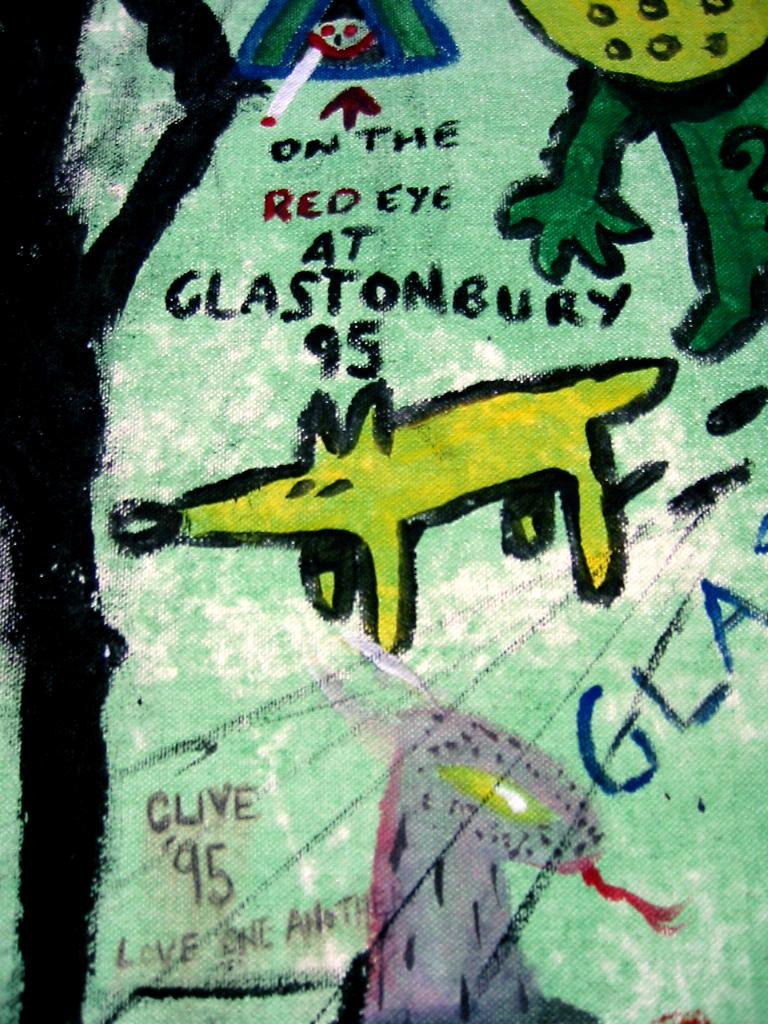<image>
Relay a brief, clear account of the picture shown. A cartoon depiction of a dog with the words On the red eye at Glastonbury 95 written above it. 